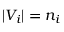<formula> <loc_0><loc_0><loc_500><loc_500>| V _ { i } | = n _ { i }</formula> 